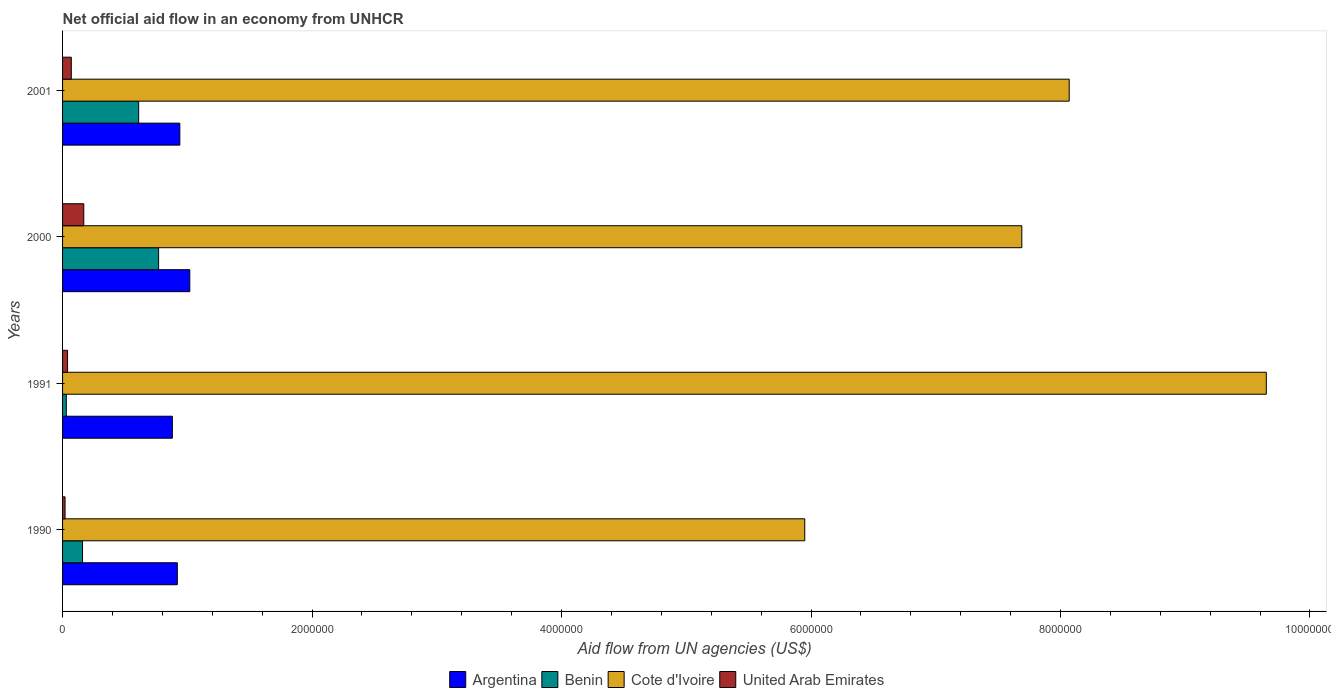How many different coloured bars are there?
Provide a short and direct response. 4. Are the number of bars per tick equal to the number of legend labels?
Make the answer very short. Yes. Are the number of bars on each tick of the Y-axis equal?
Offer a terse response. Yes. How many bars are there on the 1st tick from the top?
Your response must be concise. 4. How many bars are there on the 3rd tick from the bottom?
Offer a very short reply. 4. What is the label of the 1st group of bars from the top?
Offer a terse response. 2001. In how many cases, is the number of bars for a given year not equal to the number of legend labels?
Provide a short and direct response. 0. Across all years, what is the maximum net official aid flow in Argentina?
Ensure brevity in your answer.  1.02e+06. Across all years, what is the minimum net official aid flow in Cote d'Ivoire?
Offer a very short reply. 5.95e+06. In which year was the net official aid flow in Argentina maximum?
Provide a succinct answer. 2000. In which year was the net official aid flow in Cote d'Ivoire minimum?
Your answer should be compact. 1990. What is the total net official aid flow in Benin in the graph?
Your answer should be very brief. 1.57e+06. What is the difference between the net official aid flow in Cote d'Ivoire in 1990 and that in 2001?
Your answer should be very brief. -2.12e+06. What is the average net official aid flow in United Arab Emirates per year?
Your response must be concise. 7.50e+04. In the year 2000, what is the difference between the net official aid flow in Argentina and net official aid flow in Cote d'Ivoire?
Offer a very short reply. -6.67e+06. What is the ratio of the net official aid flow in Argentina in 1990 to that in 2000?
Provide a succinct answer. 0.9. Is the difference between the net official aid flow in Argentina in 1990 and 2001 greater than the difference between the net official aid flow in Cote d'Ivoire in 1990 and 2001?
Offer a very short reply. Yes. What is the difference between the highest and the second highest net official aid flow in Benin?
Offer a very short reply. 1.60e+05. What is the difference between the highest and the lowest net official aid flow in Benin?
Give a very brief answer. 7.40e+05. In how many years, is the net official aid flow in Argentina greater than the average net official aid flow in Argentina taken over all years?
Offer a terse response. 1. What does the 2nd bar from the top in 2001 represents?
Your answer should be compact. Cote d'Ivoire. What does the 1st bar from the bottom in 1990 represents?
Provide a short and direct response. Argentina. Is it the case that in every year, the sum of the net official aid flow in United Arab Emirates and net official aid flow in Argentina is greater than the net official aid flow in Cote d'Ivoire?
Your answer should be compact. No. How many years are there in the graph?
Give a very brief answer. 4. Does the graph contain any zero values?
Offer a very short reply. No. What is the title of the graph?
Your response must be concise. Net official aid flow in an economy from UNHCR. Does "Finland" appear as one of the legend labels in the graph?
Make the answer very short. No. What is the label or title of the X-axis?
Ensure brevity in your answer.  Aid flow from UN agencies (US$). What is the Aid flow from UN agencies (US$) in Argentina in 1990?
Your response must be concise. 9.20e+05. What is the Aid flow from UN agencies (US$) of Benin in 1990?
Your answer should be compact. 1.60e+05. What is the Aid flow from UN agencies (US$) in Cote d'Ivoire in 1990?
Give a very brief answer. 5.95e+06. What is the Aid flow from UN agencies (US$) of Argentina in 1991?
Your response must be concise. 8.80e+05. What is the Aid flow from UN agencies (US$) in Benin in 1991?
Provide a succinct answer. 3.00e+04. What is the Aid flow from UN agencies (US$) of Cote d'Ivoire in 1991?
Keep it short and to the point. 9.65e+06. What is the Aid flow from UN agencies (US$) of Argentina in 2000?
Offer a very short reply. 1.02e+06. What is the Aid flow from UN agencies (US$) in Benin in 2000?
Your response must be concise. 7.70e+05. What is the Aid flow from UN agencies (US$) in Cote d'Ivoire in 2000?
Give a very brief answer. 7.69e+06. What is the Aid flow from UN agencies (US$) of United Arab Emirates in 2000?
Provide a succinct answer. 1.70e+05. What is the Aid flow from UN agencies (US$) of Argentina in 2001?
Your response must be concise. 9.40e+05. What is the Aid flow from UN agencies (US$) of Cote d'Ivoire in 2001?
Provide a succinct answer. 8.07e+06. What is the Aid flow from UN agencies (US$) of United Arab Emirates in 2001?
Make the answer very short. 7.00e+04. Across all years, what is the maximum Aid flow from UN agencies (US$) in Argentina?
Keep it short and to the point. 1.02e+06. Across all years, what is the maximum Aid flow from UN agencies (US$) of Benin?
Your answer should be very brief. 7.70e+05. Across all years, what is the maximum Aid flow from UN agencies (US$) of Cote d'Ivoire?
Your answer should be compact. 9.65e+06. Across all years, what is the maximum Aid flow from UN agencies (US$) of United Arab Emirates?
Provide a short and direct response. 1.70e+05. Across all years, what is the minimum Aid flow from UN agencies (US$) in Argentina?
Offer a terse response. 8.80e+05. Across all years, what is the minimum Aid flow from UN agencies (US$) in Benin?
Offer a very short reply. 3.00e+04. Across all years, what is the minimum Aid flow from UN agencies (US$) in Cote d'Ivoire?
Offer a terse response. 5.95e+06. Across all years, what is the minimum Aid flow from UN agencies (US$) in United Arab Emirates?
Keep it short and to the point. 2.00e+04. What is the total Aid flow from UN agencies (US$) in Argentina in the graph?
Make the answer very short. 3.76e+06. What is the total Aid flow from UN agencies (US$) in Benin in the graph?
Give a very brief answer. 1.57e+06. What is the total Aid flow from UN agencies (US$) of Cote d'Ivoire in the graph?
Give a very brief answer. 3.14e+07. What is the total Aid flow from UN agencies (US$) in United Arab Emirates in the graph?
Keep it short and to the point. 3.00e+05. What is the difference between the Aid flow from UN agencies (US$) of Cote d'Ivoire in 1990 and that in 1991?
Your response must be concise. -3.70e+06. What is the difference between the Aid flow from UN agencies (US$) of United Arab Emirates in 1990 and that in 1991?
Offer a terse response. -2.00e+04. What is the difference between the Aid flow from UN agencies (US$) of Benin in 1990 and that in 2000?
Your answer should be compact. -6.10e+05. What is the difference between the Aid flow from UN agencies (US$) of Cote d'Ivoire in 1990 and that in 2000?
Offer a very short reply. -1.74e+06. What is the difference between the Aid flow from UN agencies (US$) in United Arab Emirates in 1990 and that in 2000?
Provide a short and direct response. -1.50e+05. What is the difference between the Aid flow from UN agencies (US$) of Benin in 1990 and that in 2001?
Provide a short and direct response. -4.50e+05. What is the difference between the Aid flow from UN agencies (US$) of Cote d'Ivoire in 1990 and that in 2001?
Your answer should be compact. -2.12e+06. What is the difference between the Aid flow from UN agencies (US$) in United Arab Emirates in 1990 and that in 2001?
Offer a terse response. -5.00e+04. What is the difference between the Aid flow from UN agencies (US$) of Argentina in 1991 and that in 2000?
Your answer should be very brief. -1.40e+05. What is the difference between the Aid flow from UN agencies (US$) of Benin in 1991 and that in 2000?
Offer a very short reply. -7.40e+05. What is the difference between the Aid flow from UN agencies (US$) of Cote d'Ivoire in 1991 and that in 2000?
Your response must be concise. 1.96e+06. What is the difference between the Aid flow from UN agencies (US$) of United Arab Emirates in 1991 and that in 2000?
Your response must be concise. -1.30e+05. What is the difference between the Aid flow from UN agencies (US$) of Argentina in 1991 and that in 2001?
Ensure brevity in your answer.  -6.00e+04. What is the difference between the Aid flow from UN agencies (US$) of Benin in 1991 and that in 2001?
Offer a terse response. -5.80e+05. What is the difference between the Aid flow from UN agencies (US$) of Cote d'Ivoire in 1991 and that in 2001?
Ensure brevity in your answer.  1.58e+06. What is the difference between the Aid flow from UN agencies (US$) of United Arab Emirates in 1991 and that in 2001?
Your response must be concise. -3.00e+04. What is the difference between the Aid flow from UN agencies (US$) of Argentina in 2000 and that in 2001?
Offer a very short reply. 8.00e+04. What is the difference between the Aid flow from UN agencies (US$) of Cote d'Ivoire in 2000 and that in 2001?
Offer a terse response. -3.80e+05. What is the difference between the Aid flow from UN agencies (US$) in United Arab Emirates in 2000 and that in 2001?
Make the answer very short. 1.00e+05. What is the difference between the Aid flow from UN agencies (US$) of Argentina in 1990 and the Aid flow from UN agencies (US$) of Benin in 1991?
Your response must be concise. 8.90e+05. What is the difference between the Aid flow from UN agencies (US$) of Argentina in 1990 and the Aid flow from UN agencies (US$) of Cote d'Ivoire in 1991?
Provide a short and direct response. -8.73e+06. What is the difference between the Aid flow from UN agencies (US$) of Argentina in 1990 and the Aid flow from UN agencies (US$) of United Arab Emirates in 1991?
Your answer should be compact. 8.80e+05. What is the difference between the Aid flow from UN agencies (US$) in Benin in 1990 and the Aid flow from UN agencies (US$) in Cote d'Ivoire in 1991?
Provide a succinct answer. -9.49e+06. What is the difference between the Aid flow from UN agencies (US$) in Benin in 1990 and the Aid flow from UN agencies (US$) in United Arab Emirates in 1991?
Your answer should be very brief. 1.20e+05. What is the difference between the Aid flow from UN agencies (US$) of Cote d'Ivoire in 1990 and the Aid flow from UN agencies (US$) of United Arab Emirates in 1991?
Offer a terse response. 5.91e+06. What is the difference between the Aid flow from UN agencies (US$) in Argentina in 1990 and the Aid flow from UN agencies (US$) in Benin in 2000?
Provide a succinct answer. 1.50e+05. What is the difference between the Aid flow from UN agencies (US$) of Argentina in 1990 and the Aid flow from UN agencies (US$) of Cote d'Ivoire in 2000?
Your answer should be very brief. -6.77e+06. What is the difference between the Aid flow from UN agencies (US$) in Argentina in 1990 and the Aid flow from UN agencies (US$) in United Arab Emirates in 2000?
Offer a terse response. 7.50e+05. What is the difference between the Aid flow from UN agencies (US$) of Benin in 1990 and the Aid flow from UN agencies (US$) of Cote d'Ivoire in 2000?
Offer a terse response. -7.53e+06. What is the difference between the Aid flow from UN agencies (US$) of Cote d'Ivoire in 1990 and the Aid flow from UN agencies (US$) of United Arab Emirates in 2000?
Provide a short and direct response. 5.78e+06. What is the difference between the Aid flow from UN agencies (US$) of Argentina in 1990 and the Aid flow from UN agencies (US$) of Benin in 2001?
Offer a terse response. 3.10e+05. What is the difference between the Aid flow from UN agencies (US$) in Argentina in 1990 and the Aid flow from UN agencies (US$) in Cote d'Ivoire in 2001?
Your answer should be very brief. -7.15e+06. What is the difference between the Aid flow from UN agencies (US$) of Argentina in 1990 and the Aid flow from UN agencies (US$) of United Arab Emirates in 2001?
Your response must be concise. 8.50e+05. What is the difference between the Aid flow from UN agencies (US$) in Benin in 1990 and the Aid flow from UN agencies (US$) in Cote d'Ivoire in 2001?
Offer a terse response. -7.91e+06. What is the difference between the Aid flow from UN agencies (US$) of Cote d'Ivoire in 1990 and the Aid flow from UN agencies (US$) of United Arab Emirates in 2001?
Ensure brevity in your answer.  5.88e+06. What is the difference between the Aid flow from UN agencies (US$) in Argentina in 1991 and the Aid flow from UN agencies (US$) in Benin in 2000?
Provide a succinct answer. 1.10e+05. What is the difference between the Aid flow from UN agencies (US$) in Argentina in 1991 and the Aid flow from UN agencies (US$) in Cote d'Ivoire in 2000?
Make the answer very short. -6.81e+06. What is the difference between the Aid flow from UN agencies (US$) of Argentina in 1991 and the Aid flow from UN agencies (US$) of United Arab Emirates in 2000?
Offer a very short reply. 7.10e+05. What is the difference between the Aid flow from UN agencies (US$) in Benin in 1991 and the Aid flow from UN agencies (US$) in Cote d'Ivoire in 2000?
Give a very brief answer. -7.66e+06. What is the difference between the Aid flow from UN agencies (US$) in Benin in 1991 and the Aid flow from UN agencies (US$) in United Arab Emirates in 2000?
Your answer should be compact. -1.40e+05. What is the difference between the Aid flow from UN agencies (US$) of Cote d'Ivoire in 1991 and the Aid flow from UN agencies (US$) of United Arab Emirates in 2000?
Your answer should be very brief. 9.48e+06. What is the difference between the Aid flow from UN agencies (US$) in Argentina in 1991 and the Aid flow from UN agencies (US$) in Benin in 2001?
Your answer should be compact. 2.70e+05. What is the difference between the Aid flow from UN agencies (US$) in Argentina in 1991 and the Aid flow from UN agencies (US$) in Cote d'Ivoire in 2001?
Provide a short and direct response. -7.19e+06. What is the difference between the Aid flow from UN agencies (US$) in Argentina in 1991 and the Aid flow from UN agencies (US$) in United Arab Emirates in 2001?
Give a very brief answer. 8.10e+05. What is the difference between the Aid flow from UN agencies (US$) of Benin in 1991 and the Aid flow from UN agencies (US$) of Cote d'Ivoire in 2001?
Give a very brief answer. -8.04e+06. What is the difference between the Aid flow from UN agencies (US$) in Cote d'Ivoire in 1991 and the Aid flow from UN agencies (US$) in United Arab Emirates in 2001?
Keep it short and to the point. 9.58e+06. What is the difference between the Aid flow from UN agencies (US$) of Argentina in 2000 and the Aid flow from UN agencies (US$) of Cote d'Ivoire in 2001?
Offer a terse response. -7.05e+06. What is the difference between the Aid flow from UN agencies (US$) of Argentina in 2000 and the Aid flow from UN agencies (US$) of United Arab Emirates in 2001?
Ensure brevity in your answer.  9.50e+05. What is the difference between the Aid flow from UN agencies (US$) in Benin in 2000 and the Aid flow from UN agencies (US$) in Cote d'Ivoire in 2001?
Provide a succinct answer. -7.30e+06. What is the difference between the Aid flow from UN agencies (US$) of Cote d'Ivoire in 2000 and the Aid flow from UN agencies (US$) of United Arab Emirates in 2001?
Keep it short and to the point. 7.62e+06. What is the average Aid flow from UN agencies (US$) in Argentina per year?
Keep it short and to the point. 9.40e+05. What is the average Aid flow from UN agencies (US$) in Benin per year?
Your response must be concise. 3.92e+05. What is the average Aid flow from UN agencies (US$) of Cote d'Ivoire per year?
Provide a succinct answer. 7.84e+06. What is the average Aid flow from UN agencies (US$) in United Arab Emirates per year?
Provide a short and direct response. 7.50e+04. In the year 1990, what is the difference between the Aid flow from UN agencies (US$) in Argentina and Aid flow from UN agencies (US$) in Benin?
Provide a short and direct response. 7.60e+05. In the year 1990, what is the difference between the Aid flow from UN agencies (US$) of Argentina and Aid flow from UN agencies (US$) of Cote d'Ivoire?
Your answer should be very brief. -5.03e+06. In the year 1990, what is the difference between the Aid flow from UN agencies (US$) in Argentina and Aid flow from UN agencies (US$) in United Arab Emirates?
Make the answer very short. 9.00e+05. In the year 1990, what is the difference between the Aid flow from UN agencies (US$) of Benin and Aid flow from UN agencies (US$) of Cote d'Ivoire?
Offer a terse response. -5.79e+06. In the year 1990, what is the difference between the Aid flow from UN agencies (US$) in Cote d'Ivoire and Aid flow from UN agencies (US$) in United Arab Emirates?
Your answer should be very brief. 5.93e+06. In the year 1991, what is the difference between the Aid flow from UN agencies (US$) in Argentina and Aid flow from UN agencies (US$) in Benin?
Offer a terse response. 8.50e+05. In the year 1991, what is the difference between the Aid flow from UN agencies (US$) of Argentina and Aid flow from UN agencies (US$) of Cote d'Ivoire?
Your response must be concise. -8.77e+06. In the year 1991, what is the difference between the Aid flow from UN agencies (US$) of Argentina and Aid flow from UN agencies (US$) of United Arab Emirates?
Offer a terse response. 8.40e+05. In the year 1991, what is the difference between the Aid flow from UN agencies (US$) of Benin and Aid flow from UN agencies (US$) of Cote d'Ivoire?
Make the answer very short. -9.62e+06. In the year 1991, what is the difference between the Aid flow from UN agencies (US$) in Benin and Aid flow from UN agencies (US$) in United Arab Emirates?
Offer a very short reply. -10000. In the year 1991, what is the difference between the Aid flow from UN agencies (US$) in Cote d'Ivoire and Aid flow from UN agencies (US$) in United Arab Emirates?
Your answer should be compact. 9.61e+06. In the year 2000, what is the difference between the Aid flow from UN agencies (US$) in Argentina and Aid flow from UN agencies (US$) in Benin?
Make the answer very short. 2.50e+05. In the year 2000, what is the difference between the Aid flow from UN agencies (US$) of Argentina and Aid flow from UN agencies (US$) of Cote d'Ivoire?
Give a very brief answer. -6.67e+06. In the year 2000, what is the difference between the Aid flow from UN agencies (US$) of Argentina and Aid flow from UN agencies (US$) of United Arab Emirates?
Keep it short and to the point. 8.50e+05. In the year 2000, what is the difference between the Aid flow from UN agencies (US$) in Benin and Aid flow from UN agencies (US$) in Cote d'Ivoire?
Keep it short and to the point. -6.92e+06. In the year 2000, what is the difference between the Aid flow from UN agencies (US$) of Benin and Aid flow from UN agencies (US$) of United Arab Emirates?
Keep it short and to the point. 6.00e+05. In the year 2000, what is the difference between the Aid flow from UN agencies (US$) in Cote d'Ivoire and Aid flow from UN agencies (US$) in United Arab Emirates?
Provide a succinct answer. 7.52e+06. In the year 2001, what is the difference between the Aid flow from UN agencies (US$) of Argentina and Aid flow from UN agencies (US$) of Benin?
Make the answer very short. 3.30e+05. In the year 2001, what is the difference between the Aid flow from UN agencies (US$) in Argentina and Aid flow from UN agencies (US$) in Cote d'Ivoire?
Offer a very short reply. -7.13e+06. In the year 2001, what is the difference between the Aid flow from UN agencies (US$) in Argentina and Aid flow from UN agencies (US$) in United Arab Emirates?
Keep it short and to the point. 8.70e+05. In the year 2001, what is the difference between the Aid flow from UN agencies (US$) in Benin and Aid flow from UN agencies (US$) in Cote d'Ivoire?
Your response must be concise. -7.46e+06. In the year 2001, what is the difference between the Aid flow from UN agencies (US$) in Benin and Aid flow from UN agencies (US$) in United Arab Emirates?
Ensure brevity in your answer.  5.40e+05. What is the ratio of the Aid flow from UN agencies (US$) of Argentina in 1990 to that in 1991?
Offer a terse response. 1.05. What is the ratio of the Aid flow from UN agencies (US$) in Benin in 1990 to that in 1991?
Provide a succinct answer. 5.33. What is the ratio of the Aid flow from UN agencies (US$) of Cote d'Ivoire in 1990 to that in 1991?
Make the answer very short. 0.62. What is the ratio of the Aid flow from UN agencies (US$) in Argentina in 1990 to that in 2000?
Provide a succinct answer. 0.9. What is the ratio of the Aid flow from UN agencies (US$) of Benin in 1990 to that in 2000?
Provide a succinct answer. 0.21. What is the ratio of the Aid flow from UN agencies (US$) of Cote d'Ivoire in 1990 to that in 2000?
Make the answer very short. 0.77. What is the ratio of the Aid flow from UN agencies (US$) in United Arab Emirates in 1990 to that in 2000?
Give a very brief answer. 0.12. What is the ratio of the Aid flow from UN agencies (US$) of Argentina in 1990 to that in 2001?
Make the answer very short. 0.98. What is the ratio of the Aid flow from UN agencies (US$) of Benin in 1990 to that in 2001?
Provide a succinct answer. 0.26. What is the ratio of the Aid flow from UN agencies (US$) in Cote d'Ivoire in 1990 to that in 2001?
Make the answer very short. 0.74. What is the ratio of the Aid flow from UN agencies (US$) of United Arab Emirates in 1990 to that in 2001?
Ensure brevity in your answer.  0.29. What is the ratio of the Aid flow from UN agencies (US$) in Argentina in 1991 to that in 2000?
Ensure brevity in your answer.  0.86. What is the ratio of the Aid flow from UN agencies (US$) in Benin in 1991 to that in 2000?
Give a very brief answer. 0.04. What is the ratio of the Aid flow from UN agencies (US$) in Cote d'Ivoire in 1991 to that in 2000?
Ensure brevity in your answer.  1.25. What is the ratio of the Aid flow from UN agencies (US$) of United Arab Emirates in 1991 to that in 2000?
Your response must be concise. 0.24. What is the ratio of the Aid flow from UN agencies (US$) in Argentina in 1991 to that in 2001?
Your answer should be compact. 0.94. What is the ratio of the Aid flow from UN agencies (US$) of Benin in 1991 to that in 2001?
Your answer should be very brief. 0.05. What is the ratio of the Aid flow from UN agencies (US$) in Cote d'Ivoire in 1991 to that in 2001?
Your answer should be compact. 1.2. What is the ratio of the Aid flow from UN agencies (US$) of United Arab Emirates in 1991 to that in 2001?
Ensure brevity in your answer.  0.57. What is the ratio of the Aid flow from UN agencies (US$) in Argentina in 2000 to that in 2001?
Your response must be concise. 1.09. What is the ratio of the Aid flow from UN agencies (US$) in Benin in 2000 to that in 2001?
Offer a very short reply. 1.26. What is the ratio of the Aid flow from UN agencies (US$) of Cote d'Ivoire in 2000 to that in 2001?
Keep it short and to the point. 0.95. What is the ratio of the Aid flow from UN agencies (US$) of United Arab Emirates in 2000 to that in 2001?
Your answer should be very brief. 2.43. What is the difference between the highest and the second highest Aid flow from UN agencies (US$) in Argentina?
Offer a terse response. 8.00e+04. What is the difference between the highest and the second highest Aid flow from UN agencies (US$) of Cote d'Ivoire?
Give a very brief answer. 1.58e+06. What is the difference between the highest and the second highest Aid flow from UN agencies (US$) in United Arab Emirates?
Provide a short and direct response. 1.00e+05. What is the difference between the highest and the lowest Aid flow from UN agencies (US$) of Argentina?
Keep it short and to the point. 1.40e+05. What is the difference between the highest and the lowest Aid flow from UN agencies (US$) of Benin?
Provide a succinct answer. 7.40e+05. What is the difference between the highest and the lowest Aid flow from UN agencies (US$) of Cote d'Ivoire?
Offer a very short reply. 3.70e+06. What is the difference between the highest and the lowest Aid flow from UN agencies (US$) in United Arab Emirates?
Offer a very short reply. 1.50e+05. 